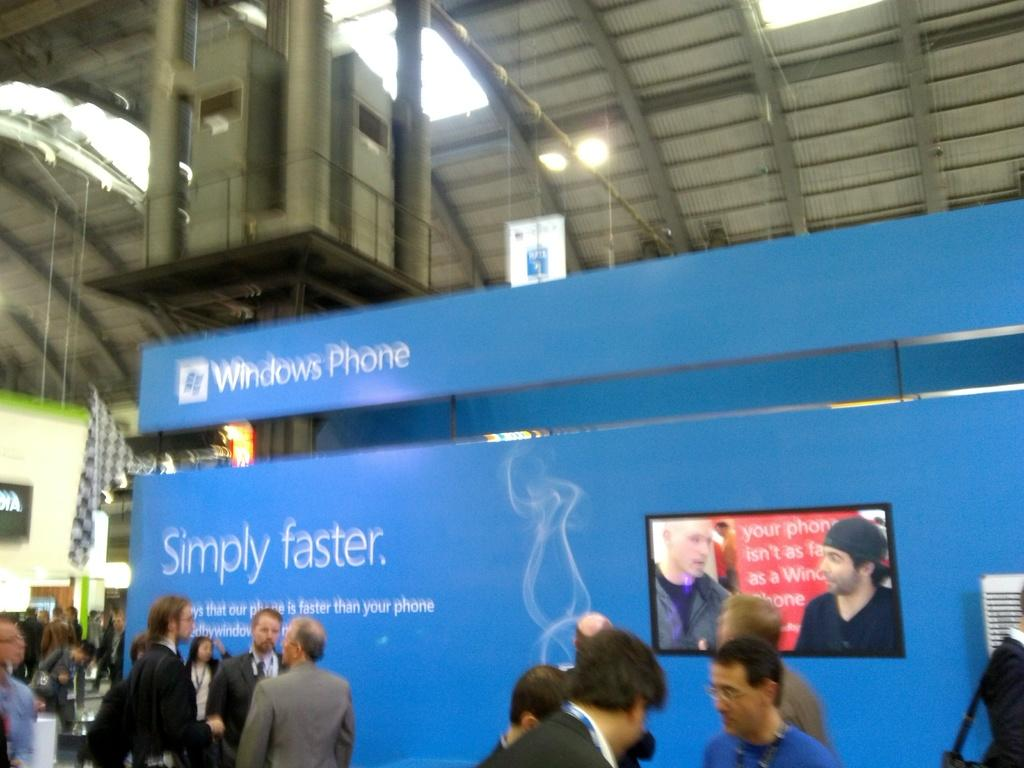What is hanging in the image? There is a banner in the image. What is on the banner? The provided facts do not specify what is on the banner. What can be seen on the screen in the image? The provided facts do not specify what is on the screen. What is attached to the wall in the image? There is a flag attached to the wall in the image. Who is present in the image? There are people present in the image. Can you tell me how many wires are connected to the stranger's device in the image? There is no stranger or device present in the image. What type of park is visible in the image? There is no park present in the image. 